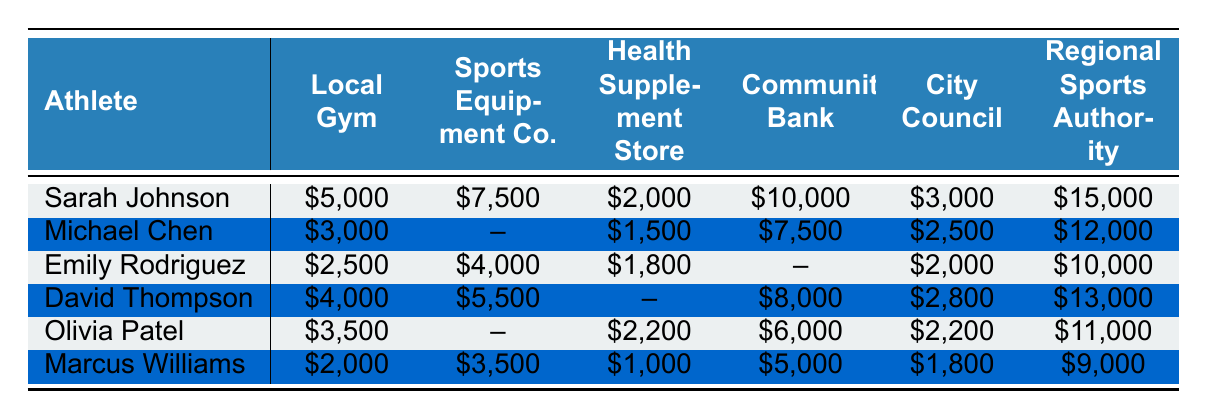What is the total sponsorship amount received by Sarah Johnson from all sources? To find the total sponsorship amount for Sarah Johnson, I will sum up the values from each sponsor's contribution: $5,000 + $2,000 + $10,000 + $3,000 + $15,000 = $35,000.
Answer: $35,000 What sponsorship amount did Michael Chen receive from the Community Bank? Michael Chen received $7,500 from the Community Bank.
Answer: $7,500 Did Emily Rodriguez receive any funding from the Sports Equipment Co.? Yes, Emily Rodriguez received $4,000 from the Sports Equipment Co.
Answer: Yes Which athlete received the highest total funding amount? I will sum the sponsorship amounts for each athlete, then compare: Sarah ($35,000), Michael ($12,000), Emily ($10,000), David ($13,000), Olivia ($11,000), Marcus ($9,000). Sarah Johnson received the highest amount with $35,000.
Answer: Sarah Johnson What is the average amount funded by the City Council to all athletes? I will calculate the average by summing the City Council contributions: $3,000 + $2,500 + $2,000 + $8,000 + $2,200 + $11,000 = $28,700. Then divide by the number of athletes (6): $28,700 / 6 = $4,783.33.
Answer: $4,783.33 How much more did David Thompson receive compared to Emily Rodriguez? David Thompson received $13,000, and Emily Rodriguez received $10,000. The difference is $13,000 - $10,000 = $3,000.
Answer: $3,000 Which sponsor contributed the least amount to Marcus Williams? For Marcus Williams, the smallest contribution was $1,000 from the Health Supplement Store.
Answer: $1,000 If I sum all funding amounts for Olivia Patel, what total do I get? For Olivia Patel, I sum her contributions: $3,500 + $2,200 + $6,000 + $2,200 + $11,000 = $25,900.
Answer: $25,900 Is there any athlete who received zero funding from the Sports Equipment Co.? Yes, Michael Chen received $0 from the Sports Equipment Co.
Answer: Yes What is the total funding from all sources for all athletes combined? I will sum all individual total amounts: $35,000 (Sarah) + $12,000 (Michael) + $10,000 (Emily) + $13,000 (David) + $25,900 (Olivia) + $9,000 (Marcus) = $104,900.
Answer: $104,900 Which athlete received the most funding from the Local Gym? Sarah Johnson received the highest amount, which is $5,000 from the Local Gym.
Answer: $5,000 